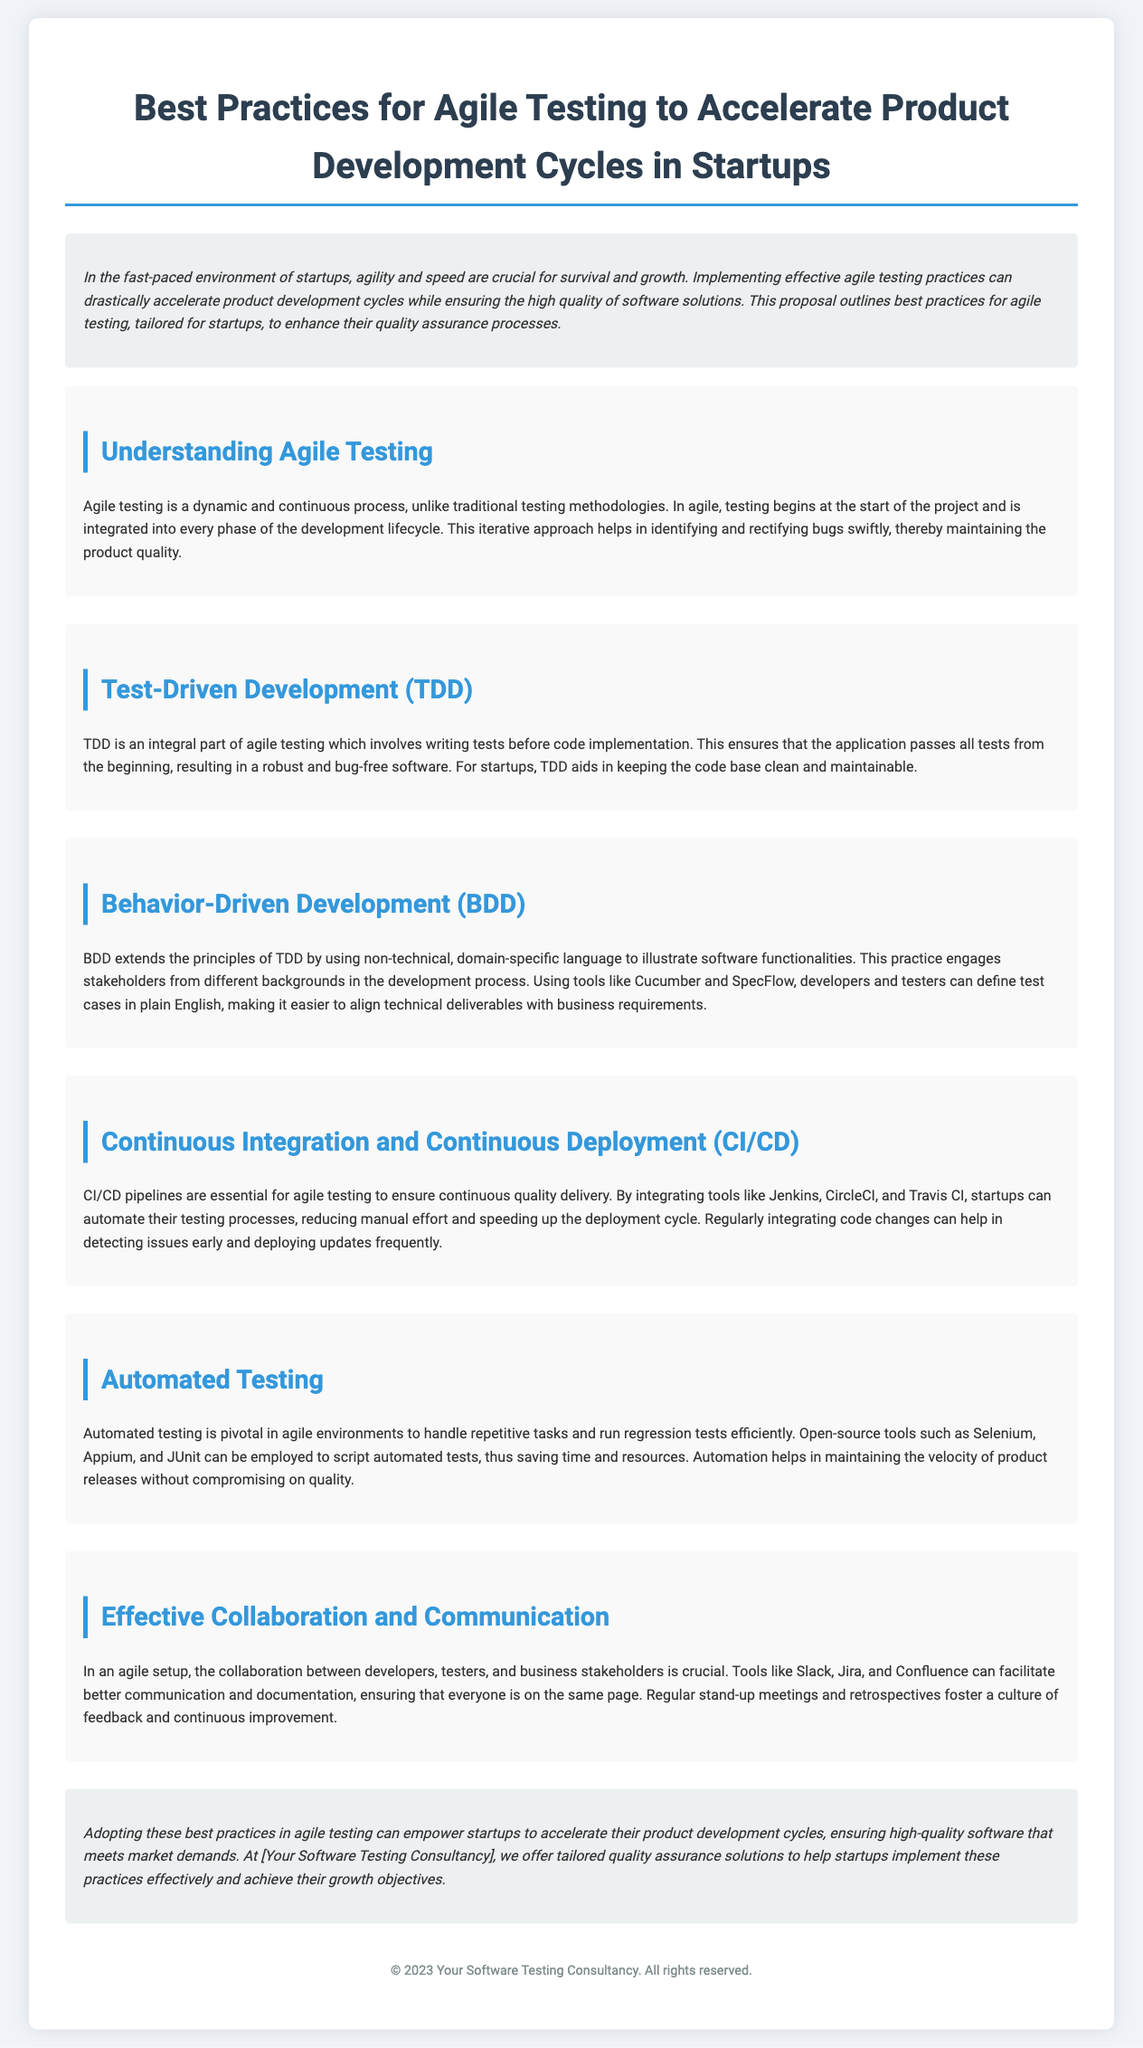What is the title of the proposal? The title of the proposal is prominently displayed at the top of the document.
Answer: Best Practices for Agile Testing to Accelerate Product Development Cycles in Startups What is the purpose of implementing effective agile testing practices? The purpose is outlined in the introduction, stating that it can drastically accelerate product development cycles while ensuring quality.
Answer: Accelerate product development cycles while ensuring quality What does TDD stand for? TDD is referenced as a key part of agile testing in the document.
Answer: Test-Driven Development What tools are mentioned for continuous integration? The section on CI/CD lists tools that aid in automation and integration.
Answer: Jenkins, CircleCI, and Travis CI What is the benefit of automated testing in agile environments? The document states that automated testing handles repetitive tasks and runs regression tests efficiently.
Answer: Handles repetitive tasks and runs regression tests efficiently Which practice engages stakeholders using domain-specific language? The section on BDD describes how this practice facilitates stakeholder engagement.
Answer: Behavior-Driven Development How do effective collaboration tools contribute to the agile process? The document emphasizes that collaboration tools ensure everyone is on the same page and fosters a culture of feedback.
Answer: Ensure everyone is on the same page and foster feedback What year is indicated at the footer of the document? The footer of the proposal provides the year related to copyright information.
Answer: 2023 What type of document is this? The structure and content focus on best practices for agile testing, indicating its nature as a proposal.
Answer: Proposal 